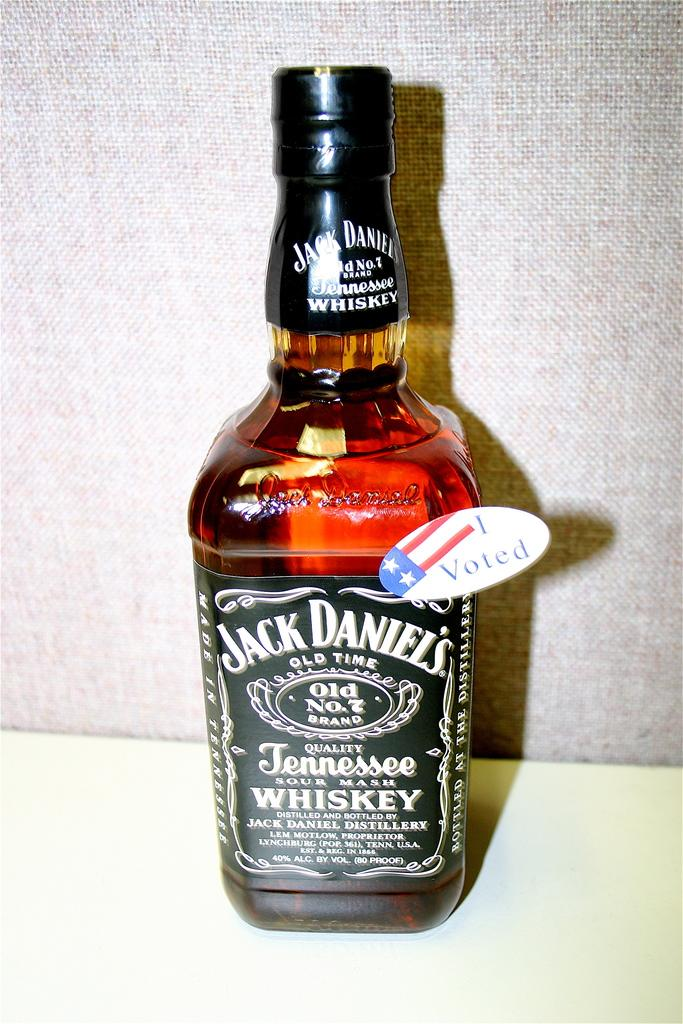<image>
Summarize the visual content of the image. a bottle of Jack Daniel's Old Time Tennessee Whiskey 